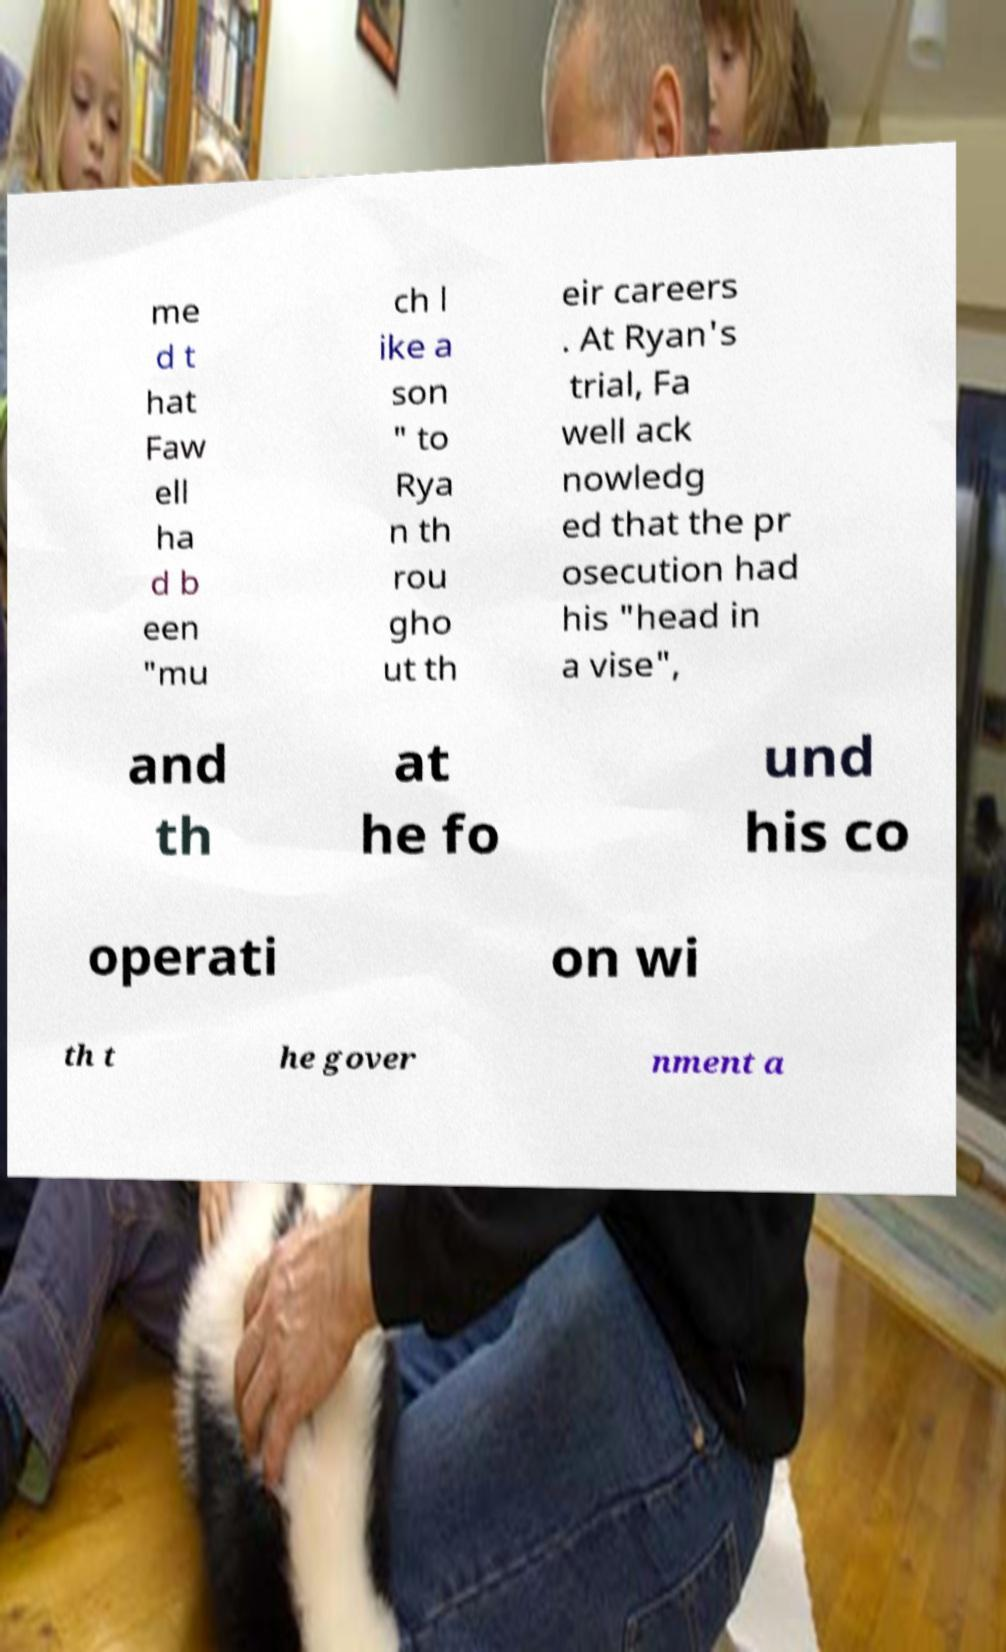Please read and relay the text visible in this image. What does it say? me d t hat Faw ell ha d b een "mu ch l ike a son " to Rya n th rou gho ut th eir careers . At Ryan's trial, Fa well ack nowledg ed that the pr osecution had his "head in a vise", and th at he fo und his co operati on wi th t he gover nment a 